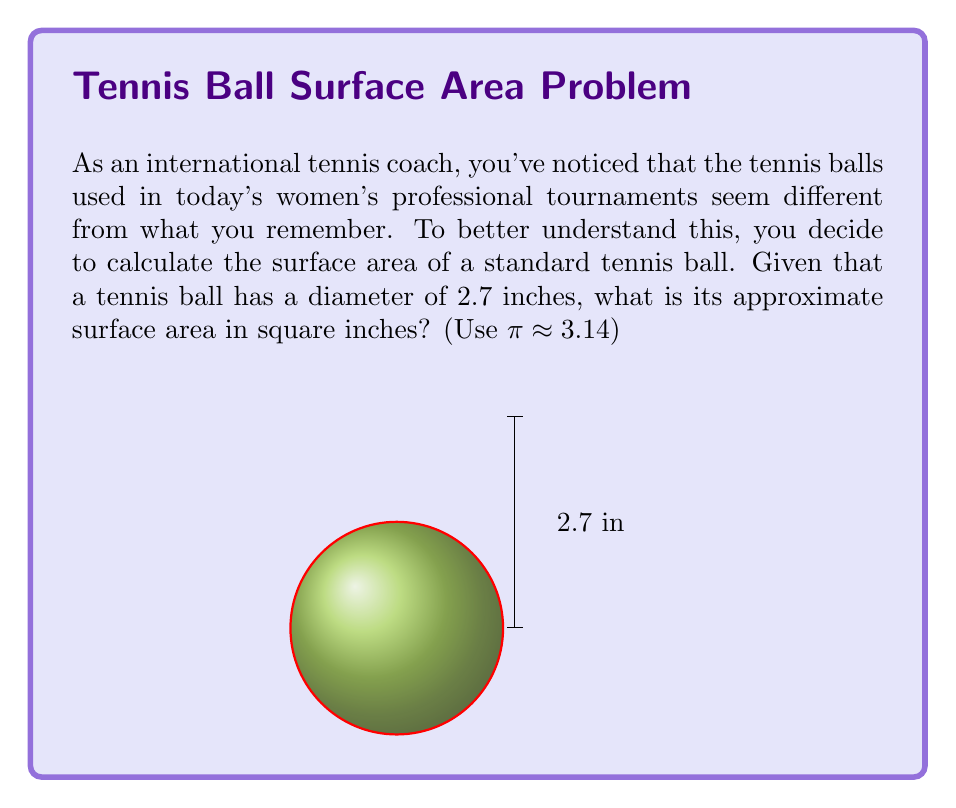Can you answer this question? Let's approach this step-by-step:

1) The formula for the surface area of a sphere is:
   $$A = 4πr^2$$
   where $r$ is the radius of the sphere.

2) We're given the diameter of the tennis ball, which is 2.7 inches. To find the radius, we divide this by 2:
   $$r = \frac{2.7}{2} = 1.35\text{ inches}$$

3) Now we can substitute this into our formula:
   $$A = 4π(1.35)^2$$

4) Let's calculate the square of the radius:
   $$1.35^2 = 1.8225$$

5) Now our equation looks like this:
   $$A = 4π(1.8225)$$

6) Multiply:
   $$A = 7.29π$$

7) Using the approximation π ≈ 3.14, we get:
   $$A ≈ 7.29 * 3.14 = 22.8906\text{ square inches}$$

8) Rounding to two decimal places:
   $$A ≈ 22.89\text{ square inches}$$
Answer: $22.89\text{ in}^2$ 